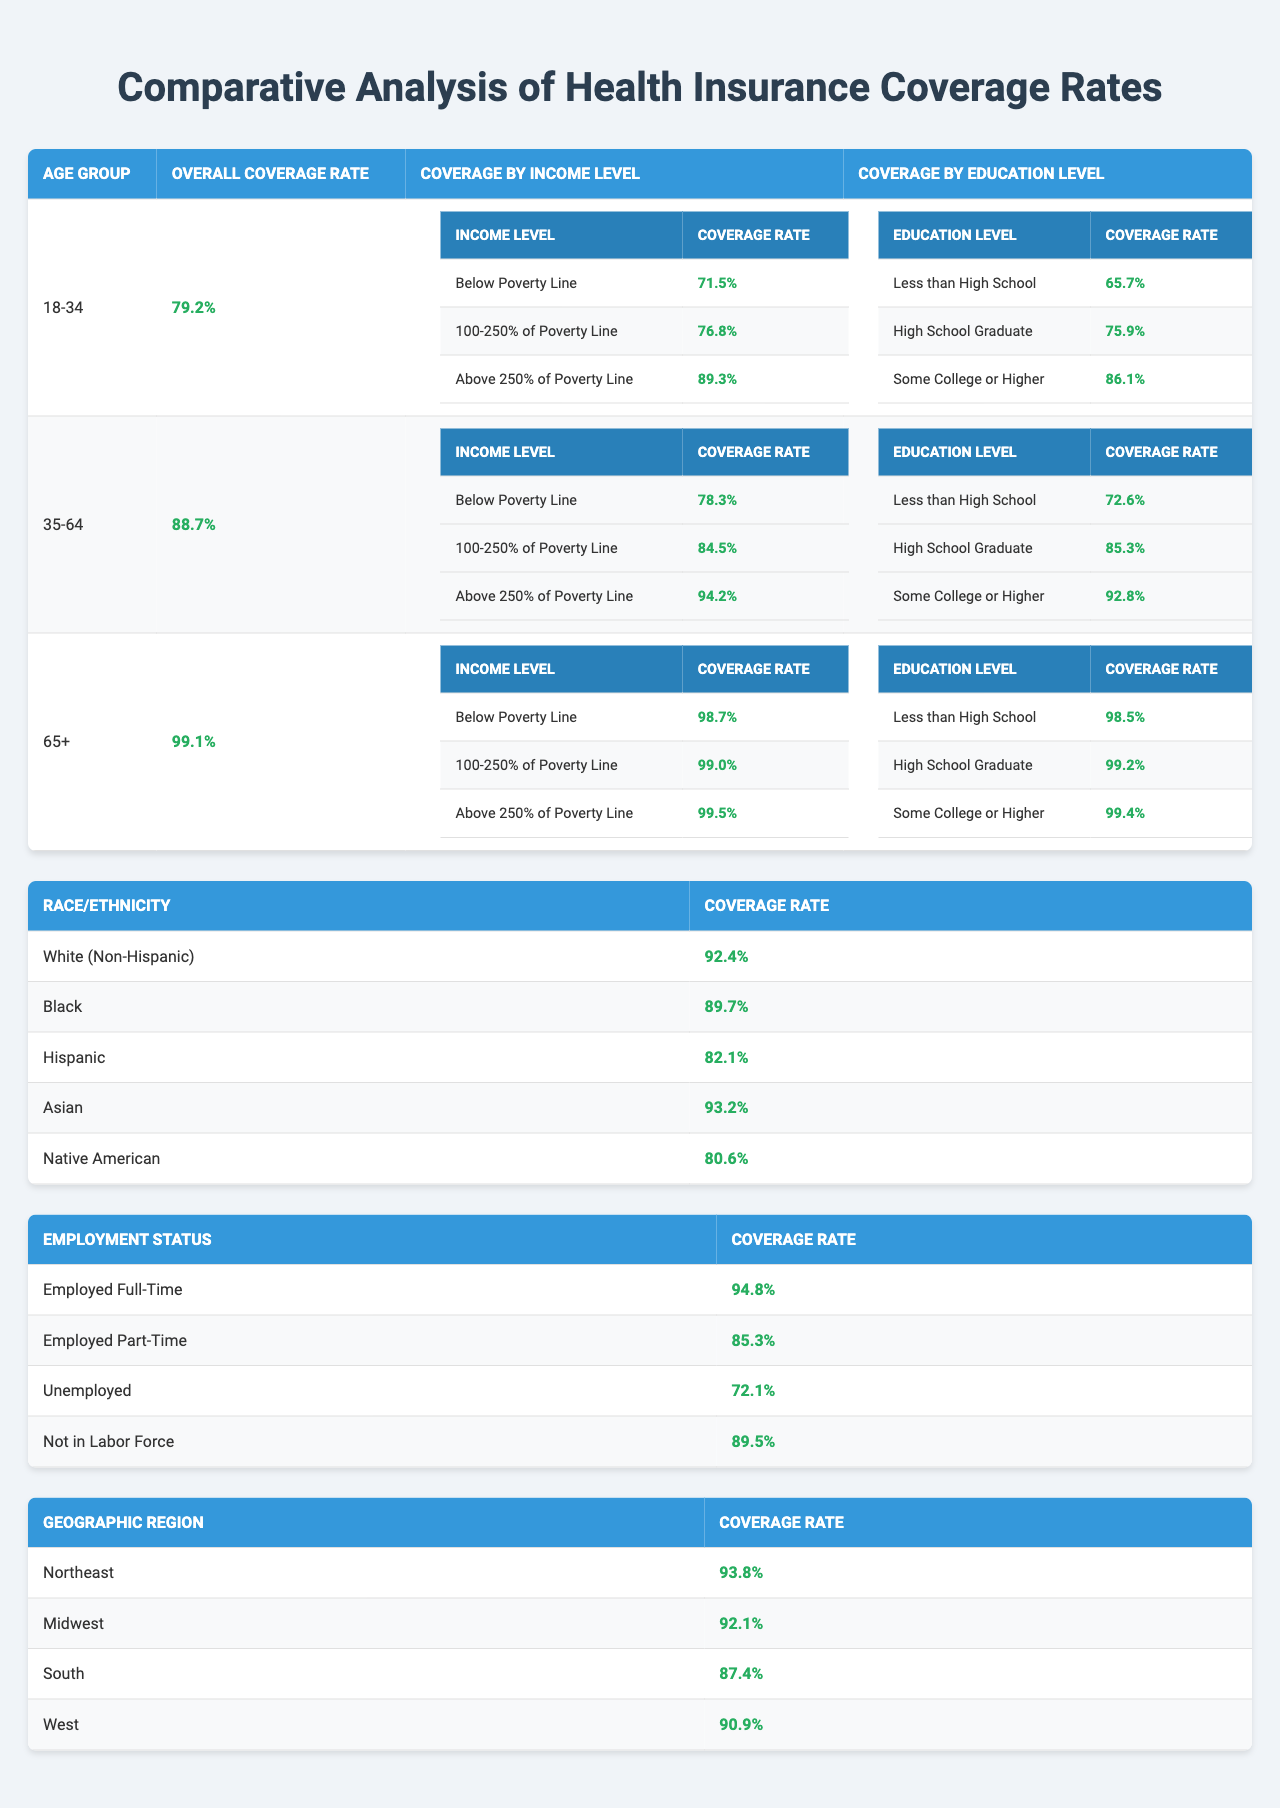What is the overall health insurance coverage rate for the age group 35-64? The table directly states that the overall coverage rate for the age group 35-64 is 88.7%.
Answer: 88.7% Which income level among the age group 18-34 has the lowest coverage rate? Looking at the coverage rates by income level for the age group 18-34, the coverage rate for "Below Poverty Line" is 71.5%, which is the lowest compared to the other income levels listed.
Answer: Below Poverty Line Is the coverage rate for individuals employed full-time higher or lower than that for part-time workers? The coverage rate for "Employed Full-Time" is 94.8%, while the rate for "Employed Part-Time" is 85.3%. Since 94.8% is greater than 85.3%, the full-time workers have a higher coverage rate.
Answer: Higher What is the difference in health insurance coverage rates between those 65 and older with a high school diploma and those with less than a high school education? The coverage rate for those 65+ with a high school diploma is 99.2%, and for those with less than high school education, it is 98.5%. To find the difference, subtract: 99.2% - 98.5% = 0.7%.
Answer: 0.7% Among the demographic groups, which race has the highest coverage rate and what is that rate? The race with the highest coverage rate is "White (Non-Hispanic)" with a rate of 92.4%, which is explicitly listed in the race/ethnicity coverage table.
Answer: White (Non-Hispanic), 92.4% Calculate the average coverage rate for the income level "Above 250% of Poverty Line" across all age groups. The coverage rates for "Above 250% of Poverty Line" are 89.3% for 18-34, 94.2% for 35-64, and 99.5% for 65+. Summing these gives 89.3% + 94.2% + 99.5% = 283%. Dividing by 3 for the average gives 283% / 3 = 94.33%.
Answer: 94.33% Is the health insurance coverage rate for unemployed individuals greater than the rate for those not in the labor force? The coverage rate for "Unemployed" is 72.1%, while "Not in Labor Force" has a rate of 89.5%. Since 72.1% is less than 89.5%, the coverage for unemployed individuals is not greater.
Answer: No What is the overall coverage rate for the age group 65+, and how does it compare to that of the age group 35-64? The overall coverage rate for the age group 65+ is 99.1%, while the coverage rate for 35-64 is 88.7%. Comparing the two rates, 99.1% is higher than 88.7%.
Answer: 99.1%, higher Which geographic region has the lowest coverage rate? Referring to the coverage by geographic region, the region with the lowest coverage rate is the "South" with 87.4%.
Answer: South, 87.4% What is the coverage rate for Hispanic individuals compared to Black individuals? The coverage rate for Hispanic individuals is 82.1% and for Black individuals is 89.7%. Comparing the two, 89.7% is higher than 82.1%.
Answer: Black individuals have a higher rate 